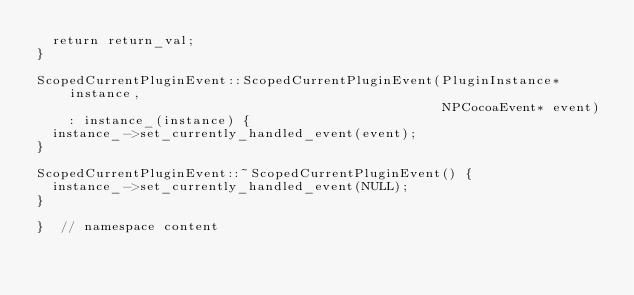<code> <loc_0><loc_0><loc_500><loc_500><_ObjectiveC_>  return return_val;
}

ScopedCurrentPluginEvent::ScopedCurrentPluginEvent(PluginInstance* instance,
                                                   NPCocoaEvent* event)
    : instance_(instance) {
  instance_->set_currently_handled_event(event);
}

ScopedCurrentPluginEvent::~ScopedCurrentPluginEvent() {
  instance_->set_currently_handled_event(NULL);
}

}  // namespace content
</code> 